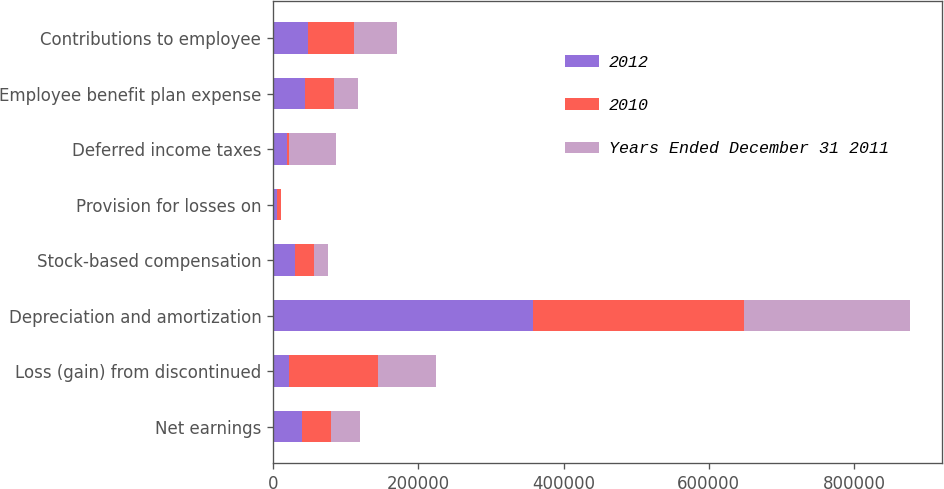<chart> <loc_0><loc_0><loc_500><loc_500><stacked_bar_chart><ecel><fcel>Net earnings<fcel>Loss (gain) from discontinued<fcel>Depreciation and amortization<fcel>Stock-based compensation<fcel>Provision for losses on<fcel>Deferred income taxes<fcel>Employee benefit plan expense<fcel>Contributions to employee<nl><fcel>2012<fcel>39954<fcel>22049<fcel>357585<fcel>30884<fcel>5162<fcel>19023<fcel>43912<fcel>48576<nl><fcel>2010<fcel>39954<fcel>122057<fcel>290477<fcel>25130<fcel>5694<fcel>3354<fcel>39954<fcel>63567<nl><fcel>Years Ended December 31 2011<fcel>39954<fcel>80607<fcel>229237<fcel>20407<fcel>153<fcel>63913<fcel>32914<fcel>58201<nl></chart> 